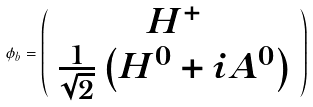<formula> <loc_0><loc_0><loc_500><loc_500>\phi _ { b } = \left ( \begin{array} { c } H ^ { + } \\ \frac { 1 } { \sqrt { 2 } } \left ( H ^ { 0 } + i A ^ { 0 } \right ) \end{array} \right )</formula> 